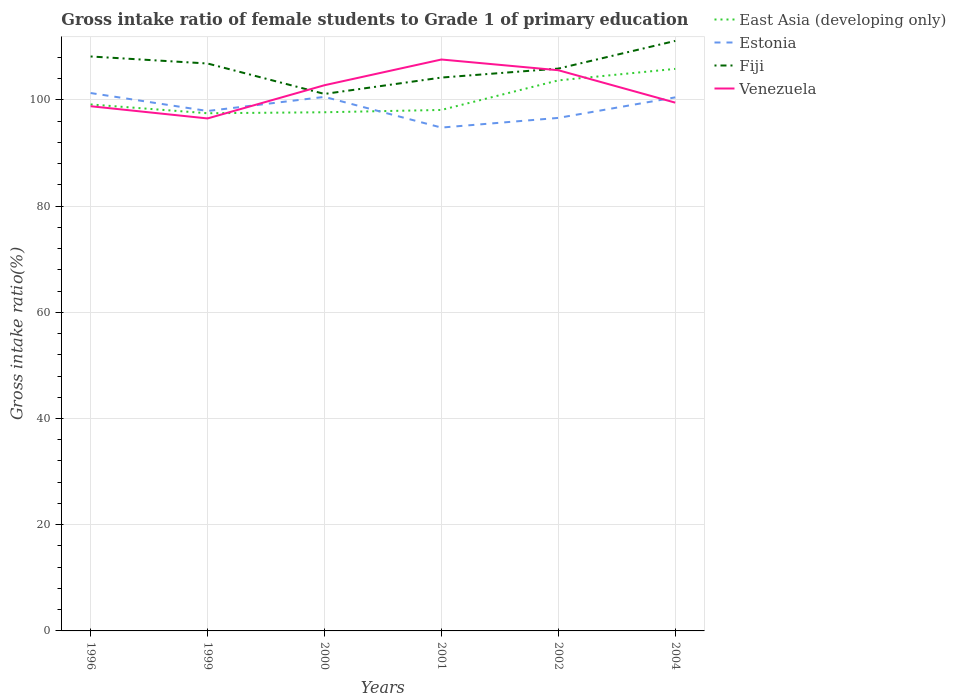How many different coloured lines are there?
Your answer should be compact. 4. Does the line corresponding to Fiji intersect with the line corresponding to Venezuela?
Provide a succinct answer. Yes. Is the number of lines equal to the number of legend labels?
Make the answer very short. Yes. Across all years, what is the maximum gross intake ratio in Estonia?
Your response must be concise. 94.78. In which year was the gross intake ratio in Venezuela maximum?
Provide a succinct answer. 1999. What is the total gross intake ratio in Estonia in the graph?
Your answer should be very brief. -5.69. What is the difference between the highest and the second highest gross intake ratio in Estonia?
Ensure brevity in your answer.  6.51. How many lines are there?
Make the answer very short. 4. What is the difference between two consecutive major ticks on the Y-axis?
Your response must be concise. 20. Are the values on the major ticks of Y-axis written in scientific E-notation?
Keep it short and to the point. No. Where does the legend appear in the graph?
Give a very brief answer. Top right. How many legend labels are there?
Keep it short and to the point. 4. How are the legend labels stacked?
Offer a terse response. Vertical. What is the title of the graph?
Make the answer very short. Gross intake ratio of female students to Grade 1 of primary education. Does "Faeroe Islands" appear as one of the legend labels in the graph?
Give a very brief answer. No. What is the label or title of the Y-axis?
Give a very brief answer. Gross intake ratio(%). What is the Gross intake ratio(%) in East Asia (developing only) in 1996?
Provide a succinct answer. 99.13. What is the Gross intake ratio(%) in Estonia in 1996?
Keep it short and to the point. 101.28. What is the Gross intake ratio(%) in Fiji in 1996?
Your response must be concise. 108.16. What is the Gross intake ratio(%) of Venezuela in 1996?
Your answer should be very brief. 98.8. What is the Gross intake ratio(%) in East Asia (developing only) in 1999?
Make the answer very short. 97.48. What is the Gross intake ratio(%) in Estonia in 1999?
Provide a short and direct response. 97.9. What is the Gross intake ratio(%) in Fiji in 1999?
Your response must be concise. 106.84. What is the Gross intake ratio(%) of Venezuela in 1999?
Offer a very short reply. 96.5. What is the Gross intake ratio(%) in East Asia (developing only) in 2000?
Offer a terse response. 97.66. What is the Gross intake ratio(%) of Estonia in 2000?
Your response must be concise. 100.55. What is the Gross intake ratio(%) of Fiji in 2000?
Keep it short and to the point. 101.11. What is the Gross intake ratio(%) of Venezuela in 2000?
Ensure brevity in your answer.  102.75. What is the Gross intake ratio(%) in East Asia (developing only) in 2001?
Make the answer very short. 98.1. What is the Gross intake ratio(%) in Estonia in 2001?
Provide a succinct answer. 94.78. What is the Gross intake ratio(%) of Fiji in 2001?
Your answer should be compact. 104.19. What is the Gross intake ratio(%) of Venezuela in 2001?
Your answer should be very brief. 107.59. What is the Gross intake ratio(%) in East Asia (developing only) in 2002?
Provide a short and direct response. 103.66. What is the Gross intake ratio(%) in Estonia in 2002?
Offer a very short reply. 96.6. What is the Gross intake ratio(%) in Fiji in 2002?
Provide a short and direct response. 105.88. What is the Gross intake ratio(%) in Venezuela in 2002?
Your answer should be compact. 105.58. What is the Gross intake ratio(%) in East Asia (developing only) in 2004?
Ensure brevity in your answer.  105.83. What is the Gross intake ratio(%) in Estonia in 2004?
Ensure brevity in your answer.  100.47. What is the Gross intake ratio(%) of Fiji in 2004?
Make the answer very short. 111.1. What is the Gross intake ratio(%) in Venezuela in 2004?
Your answer should be compact. 99.47. Across all years, what is the maximum Gross intake ratio(%) of East Asia (developing only)?
Your answer should be very brief. 105.83. Across all years, what is the maximum Gross intake ratio(%) of Estonia?
Make the answer very short. 101.28. Across all years, what is the maximum Gross intake ratio(%) of Fiji?
Keep it short and to the point. 111.1. Across all years, what is the maximum Gross intake ratio(%) in Venezuela?
Your answer should be compact. 107.59. Across all years, what is the minimum Gross intake ratio(%) of East Asia (developing only)?
Offer a very short reply. 97.48. Across all years, what is the minimum Gross intake ratio(%) of Estonia?
Your response must be concise. 94.78. Across all years, what is the minimum Gross intake ratio(%) in Fiji?
Offer a very short reply. 101.11. Across all years, what is the minimum Gross intake ratio(%) of Venezuela?
Keep it short and to the point. 96.5. What is the total Gross intake ratio(%) of East Asia (developing only) in the graph?
Provide a short and direct response. 601.86. What is the total Gross intake ratio(%) of Estonia in the graph?
Keep it short and to the point. 591.58. What is the total Gross intake ratio(%) in Fiji in the graph?
Your answer should be very brief. 637.29. What is the total Gross intake ratio(%) of Venezuela in the graph?
Offer a terse response. 610.68. What is the difference between the Gross intake ratio(%) of East Asia (developing only) in 1996 and that in 1999?
Offer a terse response. 1.66. What is the difference between the Gross intake ratio(%) of Estonia in 1996 and that in 1999?
Offer a very short reply. 3.38. What is the difference between the Gross intake ratio(%) of Fiji in 1996 and that in 1999?
Ensure brevity in your answer.  1.32. What is the difference between the Gross intake ratio(%) in Venezuela in 1996 and that in 1999?
Offer a very short reply. 2.3. What is the difference between the Gross intake ratio(%) of East Asia (developing only) in 1996 and that in 2000?
Offer a terse response. 1.47. What is the difference between the Gross intake ratio(%) in Estonia in 1996 and that in 2000?
Offer a terse response. 0.73. What is the difference between the Gross intake ratio(%) in Fiji in 1996 and that in 2000?
Provide a short and direct response. 7.05. What is the difference between the Gross intake ratio(%) of Venezuela in 1996 and that in 2000?
Keep it short and to the point. -3.95. What is the difference between the Gross intake ratio(%) of East Asia (developing only) in 1996 and that in 2001?
Provide a succinct answer. 1.04. What is the difference between the Gross intake ratio(%) in Estonia in 1996 and that in 2001?
Your answer should be compact. 6.51. What is the difference between the Gross intake ratio(%) of Fiji in 1996 and that in 2001?
Provide a succinct answer. 3.97. What is the difference between the Gross intake ratio(%) of Venezuela in 1996 and that in 2001?
Your answer should be very brief. -8.8. What is the difference between the Gross intake ratio(%) in East Asia (developing only) in 1996 and that in 2002?
Your answer should be compact. -4.53. What is the difference between the Gross intake ratio(%) of Estonia in 1996 and that in 2002?
Your answer should be very brief. 4.68. What is the difference between the Gross intake ratio(%) of Fiji in 1996 and that in 2002?
Make the answer very short. 2.28. What is the difference between the Gross intake ratio(%) of Venezuela in 1996 and that in 2002?
Offer a terse response. -6.78. What is the difference between the Gross intake ratio(%) of East Asia (developing only) in 1996 and that in 2004?
Your answer should be very brief. -6.7. What is the difference between the Gross intake ratio(%) of Estonia in 1996 and that in 2004?
Offer a very short reply. 0.82. What is the difference between the Gross intake ratio(%) in Fiji in 1996 and that in 2004?
Your answer should be compact. -2.93. What is the difference between the Gross intake ratio(%) of Venezuela in 1996 and that in 2004?
Give a very brief answer. -0.68. What is the difference between the Gross intake ratio(%) of East Asia (developing only) in 1999 and that in 2000?
Make the answer very short. -0.19. What is the difference between the Gross intake ratio(%) in Estonia in 1999 and that in 2000?
Give a very brief answer. -2.65. What is the difference between the Gross intake ratio(%) in Fiji in 1999 and that in 2000?
Offer a very short reply. 5.73. What is the difference between the Gross intake ratio(%) of Venezuela in 1999 and that in 2000?
Offer a terse response. -6.25. What is the difference between the Gross intake ratio(%) in East Asia (developing only) in 1999 and that in 2001?
Offer a terse response. -0.62. What is the difference between the Gross intake ratio(%) of Estonia in 1999 and that in 2001?
Your response must be concise. 3.12. What is the difference between the Gross intake ratio(%) in Fiji in 1999 and that in 2001?
Your answer should be compact. 2.65. What is the difference between the Gross intake ratio(%) of Venezuela in 1999 and that in 2001?
Provide a short and direct response. -11.1. What is the difference between the Gross intake ratio(%) in East Asia (developing only) in 1999 and that in 2002?
Your response must be concise. -6.19. What is the difference between the Gross intake ratio(%) in Estonia in 1999 and that in 2002?
Make the answer very short. 1.3. What is the difference between the Gross intake ratio(%) of Fiji in 1999 and that in 2002?
Provide a succinct answer. 0.96. What is the difference between the Gross intake ratio(%) in Venezuela in 1999 and that in 2002?
Your response must be concise. -9.08. What is the difference between the Gross intake ratio(%) in East Asia (developing only) in 1999 and that in 2004?
Make the answer very short. -8.35. What is the difference between the Gross intake ratio(%) in Estonia in 1999 and that in 2004?
Your answer should be compact. -2.57. What is the difference between the Gross intake ratio(%) in Fiji in 1999 and that in 2004?
Offer a terse response. -4.25. What is the difference between the Gross intake ratio(%) of Venezuela in 1999 and that in 2004?
Offer a very short reply. -2.98. What is the difference between the Gross intake ratio(%) of East Asia (developing only) in 2000 and that in 2001?
Offer a terse response. -0.44. What is the difference between the Gross intake ratio(%) in Estonia in 2000 and that in 2001?
Give a very brief answer. 5.78. What is the difference between the Gross intake ratio(%) in Fiji in 2000 and that in 2001?
Make the answer very short. -3.08. What is the difference between the Gross intake ratio(%) of Venezuela in 2000 and that in 2001?
Your response must be concise. -4.84. What is the difference between the Gross intake ratio(%) of East Asia (developing only) in 2000 and that in 2002?
Your response must be concise. -6. What is the difference between the Gross intake ratio(%) in Estonia in 2000 and that in 2002?
Provide a short and direct response. 3.96. What is the difference between the Gross intake ratio(%) in Fiji in 2000 and that in 2002?
Offer a terse response. -4.77. What is the difference between the Gross intake ratio(%) in Venezuela in 2000 and that in 2002?
Keep it short and to the point. -2.83. What is the difference between the Gross intake ratio(%) in East Asia (developing only) in 2000 and that in 2004?
Ensure brevity in your answer.  -8.17. What is the difference between the Gross intake ratio(%) of Estonia in 2000 and that in 2004?
Your answer should be very brief. 0.09. What is the difference between the Gross intake ratio(%) of Fiji in 2000 and that in 2004?
Keep it short and to the point. -9.99. What is the difference between the Gross intake ratio(%) of Venezuela in 2000 and that in 2004?
Give a very brief answer. 3.28. What is the difference between the Gross intake ratio(%) in East Asia (developing only) in 2001 and that in 2002?
Provide a succinct answer. -5.57. What is the difference between the Gross intake ratio(%) of Estonia in 2001 and that in 2002?
Ensure brevity in your answer.  -1.82. What is the difference between the Gross intake ratio(%) of Fiji in 2001 and that in 2002?
Offer a terse response. -1.69. What is the difference between the Gross intake ratio(%) in Venezuela in 2001 and that in 2002?
Your answer should be compact. 2.02. What is the difference between the Gross intake ratio(%) of East Asia (developing only) in 2001 and that in 2004?
Provide a short and direct response. -7.73. What is the difference between the Gross intake ratio(%) in Estonia in 2001 and that in 2004?
Your response must be concise. -5.69. What is the difference between the Gross intake ratio(%) of Fiji in 2001 and that in 2004?
Provide a succinct answer. -6.9. What is the difference between the Gross intake ratio(%) in Venezuela in 2001 and that in 2004?
Your response must be concise. 8.12. What is the difference between the Gross intake ratio(%) of East Asia (developing only) in 2002 and that in 2004?
Offer a terse response. -2.17. What is the difference between the Gross intake ratio(%) of Estonia in 2002 and that in 2004?
Your answer should be very brief. -3.87. What is the difference between the Gross intake ratio(%) of Fiji in 2002 and that in 2004?
Make the answer very short. -5.21. What is the difference between the Gross intake ratio(%) of Venezuela in 2002 and that in 2004?
Your response must be concise. 6.1. What is the difference between the Gross intake ratio(%) in East Asia (developing only) in 1996 and the Gross intake ratio(%) in Estonia in 1999?
Provide a short and direct response. 1.23. What is the difference between the Gross intake ratio(%) in East Asia (developing only) in 1996 and the Gross intake ratio(%) in Fiji in 1999?
Give a very brief answer. -7.71. What is the difference between the Gross intake ratio(%) in East Asia (developing only) in 1996 and the Gross intake ratio(%) in Venezuela in 1999?
Your answer should be compact. 2.64. What is the difference between the Gross intake ratio(%) in Estonia in 1996 and the Gross intake ratio(%) in Fiji in 1999?
Your response must be concise. -5.56. What is the difference between the Gross intake ratio(%) in Estonia in 1996 and the Gross intake ratio(%) in Venezuela in 1999?
Ensure brevity in your answer.  4.79. What is the difference between the Gross intake ratio(%) in Fiji in 1996 and the Gross intake ratio(%) in Venezuela in 1999?
Your answer should be compact. 11.67. What is the difference between the Gross intake ratio(%) in East Asia (developing only) in 1996 and the Gross intake ratio(%) in Estonia in 2000?
Your response must be concise. -1.42. What is the difference between the Gross intake ratio(%) in East Asia (developing only) in 1996 and the Gross intake ratio(%) in Fiji in 2000?
Provide a succinct answer. -1.98. What is the difference between the Gross intake ratio(%) of East Asia (developing only) in 1996 and the Gross intake ratio(%) of Venezuela in 2000?
Give a very brief answer. -3.62. What is the difference between the Gross intake ratio(%) of Estonia in 1996 and the Gross intake ratio(%) of Fiji in 2000?
Your answer should be very brief. 0.17. What is the difference between the Gross intake ratio(%) of Estonia in 1996 and the Gross intake ratio(%) of Venezuela in 2000?
Your answer should be very brief. -1.47. What is the difference between the Gross intake ratio(%) in Fiji in 1996 and the Gross intake ratio(%) in Venezuela in 2000?
Make the answer very short. 5.41. What is the difference between the Gross intake ratio(%) of East Asia (developing only) in 1996 and the Gross intake ratio(%) of Estonia in 2001?
Offer a very short reply. 4.36. What is the difference between the Gross intake ratio(%) of East Asia (developing only) in 1996 and the Gross intake ratio(%) of Fiji in 2001?
Provide a short and direct response. -5.06. What is the difference between the Gross intake ratio(%) in East Asia (developing only) in 1996 and the Gross intake ratio(%) in Venezuela in 2001?
Offer a very short reply. -8.46. What is the difference between the Gross intake ratio(%) of Estonia in 1996 and the Gross intake ratio(%) of Fiji in 2001?
Make the answer very short. -2.91. What is the difference between the Gross intake ratio(%) in Estonia in 1996 and the Gross intake ratio(%) in Venezuela in 2001?
Your response must be concise. -6.31. What is the difference between the Gross intake ratio(%) of Fiji in 1996 and the Gross intake ratio(%) of Venezuela in 2001?
Give a very brief answer. 0.57. What is the difference between the Gross intake ratio(%) in East Asia (developing only) in 1996 and the Gross intake ratio(%) in Estonia in 2002?
Provide a succinct answer. 2.53. What is the difference between the Gross intake ratio(%) of East Asia (developing only) in 1996 and the Gross intake ratio(%) of Fiji in 2002?
Give a very brief answer. -6.75. What is the difference between the Gross intake ratio(%) in East Asia (developing only) in 1996 and the Gross intake ratio(%) in Venezuela in 2002?
Your response must be concise. -6.44. What is the difference between the Gross intake ratio(%) of Estonia in 1996 and the Gross intake ratio(%) of Fiji in 2002?
Make the answer very short. -4.6. What is the difference between the Gross intake ratio(%) in Estonia in 1996 and the Gross intake ratio(%) in Venezuela in 2002?
Your response must be concise. -4.29. What is the difference between the Gross intake ratio(%) in Fiji in 1996 and the Gross intake ratio(%) in Venezuela in 2002?
Make the answer very short. 2.59. What is the difference between the Gross intake ratio(%) in East Asia (developing only) in 1996 and the Gross intake ratio(%) in Estonia in 2004?
Give a very brief answer. -1.33. What is the difference between the Gross intake ratio(%) of East Asia (developing only) in 1996 and the Gross intake ratio(%) of Fiji in 2004?
Offer a terse response. -11.96. What is the difference between the Gross intake ratio(%) of East Asia (developing only) in 1996 and the Gross intake ratio(%) of Venezuela in 2004?
Your answer should be compact. -0.34. What is the difference between the Gross intake ratio(%) of Estonia in 1996 and the Gross intake ratio(%) of Fiji in 2004?
Give a very brief answer. -9.81. What is the difference between the Gross intake ratio(%) of Estonia in 1996 and the Gross intake ratio(%) of Venezuela in 2004?
Your answer should be very brief. 1.81. What is the difference between the Gross intake ratio(%) of Fiji in 1996 and the Gross intake ratio(%) of Venezuela in 2004?
Give a very brief answer. 8.69. What is the difference between the Gross intake ratio(%) in East Asia (developing only) in 1999 and the Gross intake ratio(%) in Estonia in 2000?
Keep it short and to the point. -3.08. What is the difference between the Gross intake ratio(%) in East Asia (developing only) in 1999 and the Gross intake ratio(%) in Fiji in 2000?
Give a very brief answer. -3.64. What is the difference between the Gross intake ratio(%) in East Asia (developing only) in 1999 and the Gross intake ratio(%) in Venezuela in 2000?
Keep it short and to the point. -5.28. What is the difference between the Gross intake ratio(%) of Estonia in 1999 and the Gross intake ratio(%) of Fiji in 2000?
Keep it short and to the point. -3.21. What is the difference between the Gross intake ratio(%) in Estonia in 1999 and the Gross intake ratio(%) in Venezuela in 2000?
Ensure brevity in your answer.  -4.85. What is the difference between the Gross intake ratio(%) in Fiji in 1999 and the Gross intake ratio(%) in Venezuela in 2000?
Give a very brief answer. 4.09. What is the difference between the Gross intake ratio(%) in East Asia (developing only) in 1999 and the Gross intake ratio(%) in Estonia in 2001?
Offer a very short reply. 2.7. What is the difference between the Gross intake ratio(%) in East Asia (developing only) in 1999 and the Gross intake ratio(%) in Fiji in 2001?
Make the answer very short. -6.72. What is the difference between the Gross intake ratio(%) of East Asia (developing only) in 1999 and the Gross intake ratio(%) of Venezuela in 2001?
Keep it short and to the point. -10.12. What is the difference between the Gross intake ratio(%) in Estonia in 1999 and the Gross intake ratio(%) in Fiji in 2001?
Keep it short and to the point. -6.29. What is the difference between the Gross intake ratio(%) in Estonia in 1999 and the Gross intake ratio(%) in Venezuela in 2001?
Make the answer very short. -9.69. What is the difference between the Gross intake ratio(%) in Fiji in 1999 and the Gross intake ratio(%) in Venezuela in 2001?
Offer a very short reply. -0.75. What is the difference between the Gross intake ratio(%) of East Asia (developing only) in 1999 and the Gross intake ratio(%) of Estonia in 2002?
Offer a terse response. 0.88. What is the difference between the Gross intake ratio(%) in East Asia (developing only) in 1999 and the Gross intake ratio(%) in Fiji in 2002?
Your answer should be compact. -8.41. What is the difference between the Gross intake ratio(%) of East Asia (developing only) in 1999 and the Gross intake ratio(%) of Venezuela in 2002?
Make the answer very short. -8.1. What is the difference between the Gross intake ratio(%) in Estonia in 1999 and the Gross intake ratio(%) in Fiji in 2002?
Provide a short and direct response. -7.98. What is the difference between the Gross intake ratio(%) in Estonia in 1999 and the Gross intake ratio(%) in Venezuela in 2002?
Offer a terse response. -7.68. What is the difference between the Gross intake ratio(%) in Fiji in 1999 and the Gross intake ratio(%) in Venezuela in 2002?
Give a very brief answer. 1.27. What is the difference between the Gross intake ratio(%) of East Asia (developing only) in 1999 and the Gross intake ratio(%) of Estonia in 2004?
Offer a very short reply. -2.99. What is the difference between the Gross intake ratio(%) of East Asia (developing only) in 1999 and the Gross intake ratio(%) of Fiji in 2004?
Keep it short and to the point. -13.62. What is the difference between the Gross intake ratio(%) of East Asia (developing only) in 1999 and the Gross intake ratio(%) of Venezuela in 2004?
Your answer should be compact. -2. What is the difference between the Gross intake ratio(%) in Estonia in 1999 and the Gross intake ratio(%) in Fiji in 2004?
Provide a succinct answer. -13.2. What is the difference between the Gross intake ratio(%) in Estonia in 1999 and the Gross intake ratio(%) in Venezuela in 2004?
Your response must be concise. -1.57. What is the difference between the Gross intake ratio(%) of Fiji in 1999 and the Gross intake ratio(%) of Venezuela in 2004?
Your answer should be very brief. 7.37. What is the difference between the Gross intake ratio(%) in East Asia (developing only) in 2000 and the Gross intake ratio(%) in Estonia in 2001?
Ensure brevity in your answer.  2.89. What is the difference between the Gross intake ratio(%) in East Asia (developing only) in 2000 and the Gross intake ratio(%) in Fiji in 2001?
Offer a terse response. -6.53. What is the difference between the Gross intake ratio(%) in East Asia (developing only) in 2000 and the Gross intake ratio(%) in Venezuela in 2001?
Give a very brief answer. -9.93. What is the difference between the Gross intake ratio(%) in Estonia in 2000 and the Gross intake ratio(%) in Fiji in 2001?
Provide a succinct answer. -3.64. What is the difference between the Gross intake ratio(%) of Estonia in 2000 and the Gross intake ratio(%) of Venezuela in 2001?
Offer a very short reply. -7.04. What is the difference between the Gross intake ratio(%) in Fiji in 2000 and the Gross intake ratio(%) in Venezuela in 2001?
Offer a very short reply. -6.48. What is the difference between the Gross intake ratio(%) of East Asia (developing only) in 2000 and the Gross intake ratio(%) of Estonia in 2002?
Offer a terse response. 1.06. What is the difference between the Gross intake ratio(%) in East Asia (developing only) in 2000 and the Gross intake ratio(%) in Fiji in 2002?
Your answer should be compact. -8.22. What is the difference between the Gross intake ratio(%) of East Asia (developing only) in 2000 and the Gross intake ratio(%) of Venezuela in 2002?
Offer a very short reply. -7.91. What is the difference between the Gross intake ratio(%) in Estonia in 2000 and the Gross intake ratio(%) in Fiji in 2002?
Keep it short and to the point. -5.33. What is the difference between the Gross intake ratio(%) of Estonia in 2000 and the Gross intake ratio(%) of Venezuela in 2002?
Your answer should be compact. -5.02. What is the difference between the Gross intake ratio(%) in Fiji in 2000 and the Gross intake ratio(%) in Venezuela in 2002?
Your response must be concise. -4.47. What is the difference between the Gross intake ratio(%) of East Asia (developing only) in 2000 and the Gross intake ratio(%) of Estonia in 2004?
Give a very brief answer. -2.8. What is the difference between the Gross intake ratio(%) of East Asia (developing only) in 2000 and the Gross intake ratio(%) of Fiji in 2004?
Ensure brevity in your answer.  -13.43. What is the difference between the Gross intake ratio(%) of East Asia (developing only) in 2000 and the Gross intake ratio(%) of Venezuela in 2004?
Your answer should be very brief. -1.81. What is the difference between the Gross intake ratio(%) in Estonia in 2000 and the Gross intake ratio(%) in Fiji in 2004?
Offer a terse response. -10.54. What is the difference between the Gross intake ratio(%) of Estonia in 2000 and the Gross intake ratio(%) of Venezuela in 2004?
Keep it short and to the point. 1.08. What is the difference between the Gross intake ratio(%) of Fiji in 2000 and the Gross intake ratio(%) of Venezuela in 2004?
Keep it short and to the point. 1.64. What is the difference between the Gross intake ratio(%) of East Asia (developing only) in 2001 and the Gross intake ratio(%) of Estonia in 2002?
Offer a terse response. 1.5. What is the difference between the Gross intake ratio(%) of East Asia (developing only) in 2001 and the Gross intake ratio(%) of Fiji in 2002?
Your answer should be compact. -7.79. What is the difference between the Gross intake ratio(%) in East Asia (developing only) in 2001 and the Gross intake ratio(%) in Venezuela in 2002?
Your response must be concise. -7.48. What is the difference between the Gross intake ratio(%) in Estonia in 2001 and the Gross intake ratio(%) in Fiji in 2002?
Offer a very short reply. -11.11. What is the difference between the Gross intake ratio(%) of Estonia in 2001 and the Gross intake ratio(%) of Venezuela in 2002?
Offer a very short reply. -10.8. What is the difference between the Gross intake ratio(%) of Fiji in 2001 and the Gross intake ratio(%) of Venezuela in 2002?
Provide a succinct answer. -1.38. What is the difference between the Gross intake ratio(%) in East Asia (developing only) in 2001 and the Gross intake ratio(%) in Estonia in 2004?
Offer a terse response. -2.37. What is the difference between the Gross intake ratio(%) in East Asia (developing only) in 2001 and the Gross intake ratio(%) in Fiji in 2004?
Your response must be concise. -13. What is the difference between the Gross intake ratio(%) in East Asia (developing only) in 2001 and the Gross intake ratio(%) in Venezuela in 2004?
Offer a very short reply. -1.38. What is the difference between the Gross intake ratio(%) of Estonia in 2001 and the Gross intake ratio(%) of Fiji in 2004?
Your answer should be compact. -16.32. What is the difference between the Gross intake ratio(%) of Estonia in 2001 and the Gross intake ratio(%) of Venezuela in 2004?
Your response must be concise. -4.7. What is the difference between the Gross intake ratio(%) of Fiji in 2001 and the Gross intake ratio(%) of Venezuela in 2004?
Your answer should be compact. 4.72. What is the difference between the Gross intake ratio(%) in East Asia (developing only) in 2002 and the Gross intake ratio(%) in Estonia in 2004?
Offer a very short reply. 3.2. What is the difference between the Gross intake ratio(%) of East Asia (developing only) in 2002 and the Gross intake ratio(%) of Fiji in 2004?
Provide a short and direct response. -7.43. What is the difference between the Gross intake ratio(%) in East Asia (developing only) in 2002 and the Gross intake ratio(%) in Venezuela in 2004?
Your response must be concise. 4.19. What is the difference between the Gross intake ratio(%) of Estonia in 2002 and the Gross intake ratio(%) of Fiji in 2004?
Your answer should be compact. -14.5. What is the difference between the Gross intake ratio(%) in Estonia in 2002 and the Gross intake ratio(%) in Venezuela in 2004?
Offer a terse response. -2.87. What is the difference between the Gross intake ratio(%) in Fiji in 2002 and the Gross intake ratio(%) in Venezuela in 2004?
Keep it short and to the point. 6.41. What is the average Gross intake ratio(%) of East Asia (developing only) per year?
Your response must be concise. 100.31. What is the average Gross intake ratio(%) in Estonia per year?
Keep it short and to the point. 98.6. What is the average Gross intake ratio(%) in Fiji per year?
Your answer should be very brief. 106.22. What is the average Gross intake ratio(%) of Venezuela per year?
Your answer should be compact. 101.78. In the year 1996, what is the difference between the Gross intake ratio(%) in East Asia (developing only) and Gross intake ratio(%) in Estonia?
Ensure brevity in your answer.  -2.15. In the year 1996, what is the difference between the Gross intake ratio(%) of East Asia (developing only) and Gross intake ratio(%) of Fiji?
Your response must be concise. -9.03. In the year 1996, what is the difference between the Gross intake ratio(%) in East Asia (developing only) and Gross intake ratio(%) in Venezuela?
Your answer should be very brief. 0.34. In the year 1996, what is the difference between the Gross intake ratio(%) in Estonia and Gross intake ratio(%) in Fiji?
Make the answer very short. -6.88. In the year 1996, what is the difference between the Gross intake ratio(%) in Estonia and Gross intake ratio(%) in Venezuela?
Your response must be concise. 2.49. In the year 1996, what is the difference between the Gross intake ratio(%) in Fiji and Gross intake ratio(%) in Venezuela?
Your answer should be very brief. 9.37. In the year 1999, what is the difference between the Gross intake ratio(%) in East Asia (developing only) and Gross intake ratio(%) in Estonia?
Your answer should be compact. -0.42. In the year 1999, what is the difference between the Gross intake ratio(%) of East Asia (developing only) and Gross intake ratio(%) of Fiji?
Keep it short and to the point. -9.37. In the year 1999, what is the difference between the Gross intake ratio(%) of East Asia (developing only) and Gross intake ratio(%) of Venezuela?
Offer a very short reply. 0.98. In the year 1999, what is the difference between the Gross intake ratio(%) in Estonia and Gross intake ratio(%) in Fiji?
Keep it short and to the point. -8.94. In the year 1999, what is the difference between the Gross intake ratio(%) in Estonia and Gross intake ratio(%) in Venezuela?
Provide a succinct answer. 1.4. In the year 1999, what is the difference between the Gross intake ratio(%) in Fiji and Gross intake ratio(%) in Venezuela?
Keep it short and to the point. 10.35. In the year 2000, what is the difference between the Gross intake ratio(%) of East Asia (developing only) and Gross intake ratio(%) of Estonia?
Provide a succinct answer. -2.89. In the year 2000, what is the difference between the Gross intake ratio(%) in East Asia (developing only) and Gross intake ratio(%) in Fiji?
Your answer should be compact. -3.45. In the year 2000, what is the difference between the Gross intake ratio(%) in East Asia (developing only) and Gross intake ratio(%) in Venezuela?
Provide a succinct answer. -5.09. In the year 2000, what is the difference between the Gross intake ratio(%) of Estonia and Gross intake ratio(%) of Fiji?
Offer a very short reply. -0.56. In the year 2000, what is the difference between the Gross intake ratio(%) of Estonia and Gross intake ratio(%) of Venezuela?
Keep it short and to the point. -2.2. In the year 2000, what is the difference between the Gross intake ratio(%) of Fiji and Gross intake ratio(%) of Venezuela?
Your response must be concise. -1.64. In the year 2001, what is the difference between the Gross intake ratio(%) in East Asia (developing only) and Gross intake ratio(%) in Estonia?
Give a very brief answer. 3.32. In the year 2001, what is the difference between the Gross intake ratio(%) of East Asia (developing only) and Gross intake ratio(%) of Fiji?
Provide a short and direct response. -6.1. In the year 2001, what is the difference between the Gross intake ratio(%) in East Asia (developing only) and Gross intake ratio(%) in Venezuela?
Your answer should be very brief. -9.5. In the year 2001, what is the difference between the Gross intake ratio(%) in Estonia and Gross intake ratio(%) in Fiji?
Provide a short and direct response. -9.42. In the year 2001, what is the difference between the Gross intake ratio(%) of Estonia and Gross intake ratio(%) of Venezuela?
Offer a very short reply. -12.82. In the year 2001, what is the difference between the Gross intake ratio(%) of Fiji and Gross intake ratio(%) of Venezuela?
Provide a succinct answer. -3.4. In the year 2002, what is the difference between the Gross intake ratio(%) of East Asia (developing only) and Gross intake ratio(%) of Estonia?
Keep it short and to the point. 7.06. In the year 2002, what is the difference between the Gross intake ratio(%) in East Asia (developing only) and Gross intake ratio(%) in Fiji?
Make the answer very short. -2.22. In the year 2002, what is the difference between the Gross intake ratio(%) of East Asia (developing only) and Gross intake ratio(%) of Venezuela?
Provide a succinct answer. -1.91. In the year 2002, what is the difference between the Gross intake ratio(%) in Estonia and Gross intake ratio(%) in Fiji?
Offer a very short reply. -9.28. In the year 2002, what is the difference between the Gross intake ratio(%) of Estonia and Gross intake ratio(%) of Venezuela?
Your answer should be very brief. -8.98. In the year 2002, what is the difference between the Gross intake ratio(%) in Fiji and Gross intake ratio(%) in Venezuela?
Your response must be concise. 0.31. In the year 2004, what is the difference between the Gross intake ratio(%) of East Asia (developing only) and Gross intake ratio(%) of Estonia?
Provide a succinct answer. 5.36. In the year 2004, what is the difference between the Gross intake ratio(%) in East Asia (developing only) and Gross intake ratio(%) in Fiji?
Provide a succinct answer. -5.27. In the year 2004, what is the difference between the Gross intake ratio(%) of East Asia (developing only) and Gross intake ratio(%) of Venezuela?
Make the answer very short. 6.36. In the year 2004, what is the difference between the Gross intake ratio(%) of Estonia and Gross intake ratio(%) of Fiji?
Give a very brief answer. -10.63. In the year 2004, what is the difference between the Gross intake ratio(%) in Fiji and Gross intake ratio(%) in Venezuela?
Your answer should be compact. 11.62. What is the ratio of the Gross intake ratio(%) in Estonia in 1996 to that in 1999?
Give a very brief answer. 1.03. What is the ratio of the Gross intake ratio(%) in Fiji in 1996 to that in 1999?
Provide a short and direct response. 1.01. What is the ratio of the Gross intake ratio(%) in Venezuela in 1996 to that in 1999?
Offer a very short reply. 1.02. What is the ratio of the Gross intake ratio(%) of East Asia (developing only) in 1996 to that in 2000?
Keep it short and to the point. 1.02. What is the ratio of the Gross intake ratio(%) of Estonia in 1996 to that in 2000?
Provide a short and direct response. 1.01. What is the ratio of the Gross intake ratio(%) in Fiji in 1996 to that in 2000?
Give a very brief answer. 1.07. What is the ratio of the Gross intake ratio(%) in Venezuela in 1996 to that in 2000?
Your answer should be very brief. 0.96. What is the ratio of the Gross intake ratio(%) of East Asia (developing only) in 1996 to that in 2001?
Your response must be concise. 1.01. What is the ratio of the Gross intake ratio(%) in Estonia in 1996 to that in 2001?
Provide a short and direct response. 1.07. What is the ratio of the Gross intake ratio(%) in Fiji in 1996 to that in 2001?
Provide a short and direct response. 1.04. What is the ratio of the Gross intake ratio(%) of Venezuela in 1996 to that in 2001?
Make the answer very short. 0.92. What is the ratio of the Gross intake ratio(%) in East Asia (developing only) in 1996 to that in 2002?
Your answer should be very brief. 0.96. What is the ratio of the Gross intake ratio(%) in Estonia in 1996 to that in 2002?
Your answer should be compact. 1.05. What is the ratio of the Gross intake ratio(%) in Fiji in 1996 to that in 2002?
Offer a terse response. 1.02. What is the ratio of the Gross intake ratio(%) in Venezuela in 1996 to that in 2002?
Your answer should be compact. 0.94. What is the ratio of the Gross intake ratio(%) in East Asia (developing only) in 1996 to that in 2004?
Offer a very short reply. 0.94. What is the ratio of the Gross intake ratio(%) of Fiji in 1996 to that in 2004?
Your answer should be compact. 0.97. What is the ratio of the Gross intake ratio(%) of Venezuela in 1996 to that in 2004?
Your response must be concise. 0.99. What is the ratio of the Gross intake ratio(%) in East Asia (developing only) in 1999 to that in 2000?
Offer a terse response. 1. What is the ratio of the Gross intake ratio(%) of Estonia in 1999 to that in 2000?
Ensure brevity in your answer.  0.97. What is the ratio of the Gross intake ratio(%) of Fiji in 1999 to that in 2000?
Ensure brevity in your answer.  1.06. What is the ratio of the Gross intake ratio(%) in Venezuela in 1999 to that in 2000?
Your answer should be very brief. 0.94. What is the ratio of the Gross intake ratio(%) in Estonia in 1999 to that in 2001?
Keep it short and to the point. 1.03. What is the ratio of the Gross intake ratio(%) in Fiji in 1999 to that in 2001?
Keep it short and to the point. 1.03. What is the ratio of the Gross intake ratio(%) in Venezuela in 1999 to that in 2001?
Ensure brevity in your answer.  0.9. What is the ratio of the Gross intake ratio(%) in East Asia (developing only) in 1999 to that in 2002?
Make the answer very short. 0.94. What is the ratio of the Gross intake ratio(%) in Estonia in 1999 to that in 2002?
Offer a terse response. 1.01. What is the ratio of the Gross intake ratio(%) in Fiji in 1999 to that in 2002?
Your answer should be very brief. 1.01. What is the ratio of the Gross intake ratio(%) of Venezuela in 1999 to that in 2002?
Provide a short and direct response. 0.91. What is the ratio of the Gross intake ratio(%) of East Asia (developing only) in 1999 to that in 2004?
Provide a short and direct response. 0.92. What is the ratio of the Gross intake ratio(%) in Estonia in 1999 to that in 2004?
Your answer should be compact. 0.97. What is the ratio of the Gross intake ratio(%) of Fiji in 1999 to that in 2004?
Your answer should be very brief. 0.96. What is the ratio of the Gross intake ratio(%) of Venezuela in 1999 to that in 2004?
Your answer should be very brief. 0.97. What is the ratio of the Gross intake ratio(%) in East Asia (developing only) in 2000 to that in 2001?
Provide a short and direct response. 1. What is the ratio of the Gross intake ratio(%) in Estonia in 2000 to that in 2001?
Make the answer very short. 1.06. What is the ratio of the Gross intake ratio(%) in Fiji in 2000 to that in 2001?
Offer a terse response. 0.97. What is the ratio of the Gross intake ratio(%) of Venezuela in 2000 to that in 2001?
Offer a very short reply. 0.95. What is the ratio of the Gross intake ratio(%) in East Asia (developing only) in 2000 to that in 2002?
Your answer should be compact. 0.94. What is the ratio of the Gross intake ratio(%) in Estonia in 2000 to that in 2002?
Offer a terse response. 1.04. What is the ratio of the Gross intake ratio(%) of Fiji in 2000 to that in 2002?
Make the answer very short. 0.95. What is the ratio of the Gross intake ratio(%) of Venezuela in 2000 to that in 2002?
Make the answer very short. 0.97. What is the ratio of the Gross intake ratio(%) of East Asia (developing only) in 2000 to that in 2004?
Make the answer very short. 0.92. What is the ratio of the Gross intake ratio(%) in Estonia in 2000 to that in 2004?
Provide a succinct answer. 1. What is the ratio of the Gross intake ratio(%) of Fiji in 2000 to that in 2004?
Keep it short and to the point. 0.91. What is the ratio of the Gross intake ratio(%) in Venezuela in 2000 to that in 2004?
Keep it short and to the point. 1.03. What is the ratio of the Gross intake ratio(%) in East Asia (developing only) in 2001 to that in 2002?
Your response must be concise. 0.95. What is the ratio of the Gross intake ratio(%) in Estonia in 2001 to that in 2002?
Ensure brevity in your answer.  0.98. What is the ratio of the Gross intake ratio(%) in Venezuela in 2001 to that in 2002?
Provide a short and direct response. 1.02. What is the ratio of the Gross intake ratio(%) of East Asia (developing only) in 2001 to that in 2004?
Give a very brief answer. 0.93. What is the ratio of the Gross intake ratio(%) in Estonia in 2001 to that in 2004?
Offer a terse response. 0.94. What is the ratio of the Gross intake ratio(%) of Fiji in 2001 to that in 2004?
Ensure brevity in your answer.  0.94. What is the ratio of the Gross intake ratio(%) in Venezuela in 2001 to that in 2004?
Your answer should be compact. 1.08. What is the ratio of the Gross intake ratio(%) of East Asia (developing only) in 2002 to that in 2004?
Give a very brief answer. 0.98. What is the ratio of the Gross intake ratio(%) of Estonia in 2002 to that in 2004?
Your answer should be compact. 0.96. What is the ratio of the Gross intake ratio(%) of Fiji in 2002 to that in 2004?
Give a very brief answer. 0.95. What is the ratio of the Gross intake ratio(%) in Venezuela in 2002 to that in 2004?
Offer a terse response. 1.06. What is the difference between the highest and the second highest Gross intake ratio(%) in East Asia (developing only)?
Your answer should be very brief. 2.17. What is the difference between the highest and the second highest Gross intake ratio(%) of Estonia?
Your answer should be very brief. 0.73. What is the difference between the highest and the second highest Gross intake ratio(%) of Fiji?
Your answer should be very brief. 2.93. What is the difference between the highest and the second highest Gross intake ratio(%) in Venezuela?
Give a very brief answer. 2.02. What is the difference between the highest and the lowest Gross intake ratio(%) in East Asia (developing only)?
Your response must be concise. 8.35. What is the difference between the highest and the lowest Gross intake ratio(%) of Estonia?
Ensure brevity in your answer.  6.51. What is the difference between the highest and the lowest Gross intake ratio(%) of Fiji?
Provide a succinct answer. 9.99. What is the difference between the highest and the lowest Gross intake ratio(%) of Venezuela?
Offer a very short reply. 11.1. 